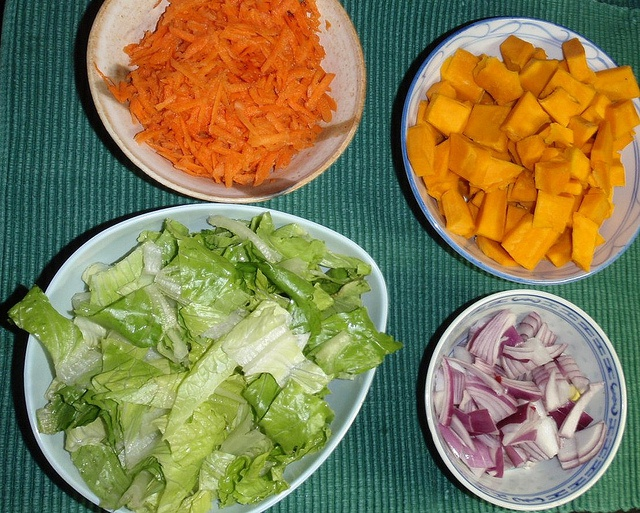Describe the objects in this image and their specific colors. I can see dining table in black, teal, and darkgreen tones, bowl in black, olive, darkgray, and darkgreen tones, bowl in black, orange, red, and darkgray tones, bowl in black, red, tan, and brown tones, and bowl in black, darkgray, lightgray, and gray tones in this image. 